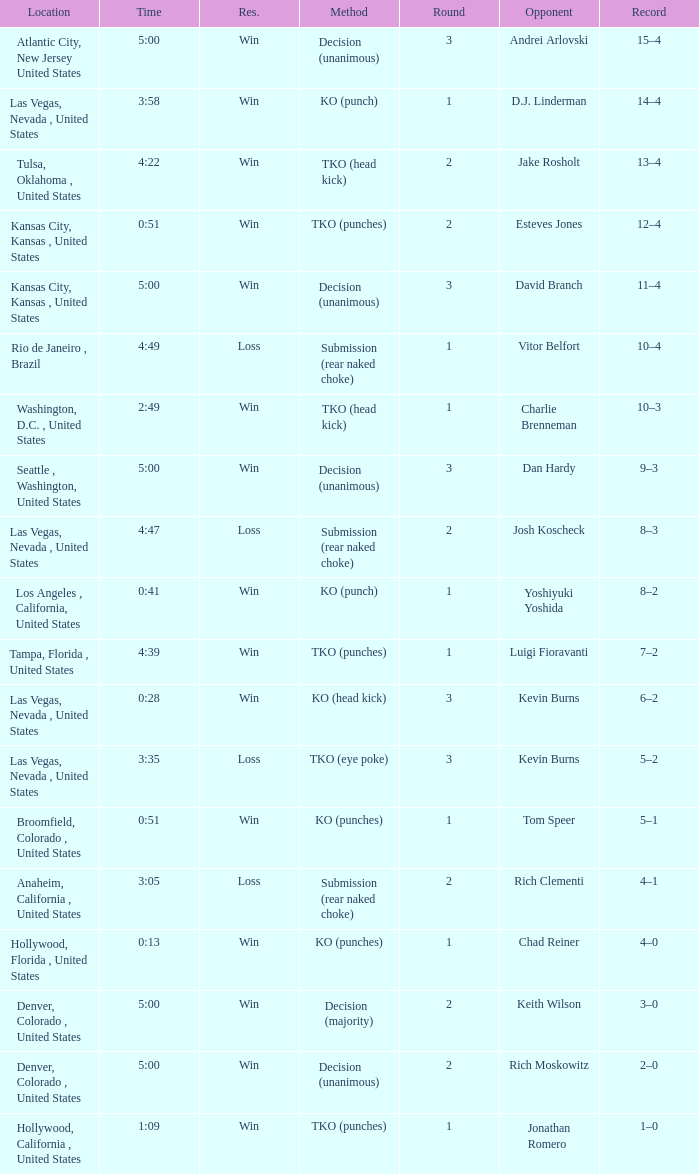Which record has a time of 0:13? 4–0. 